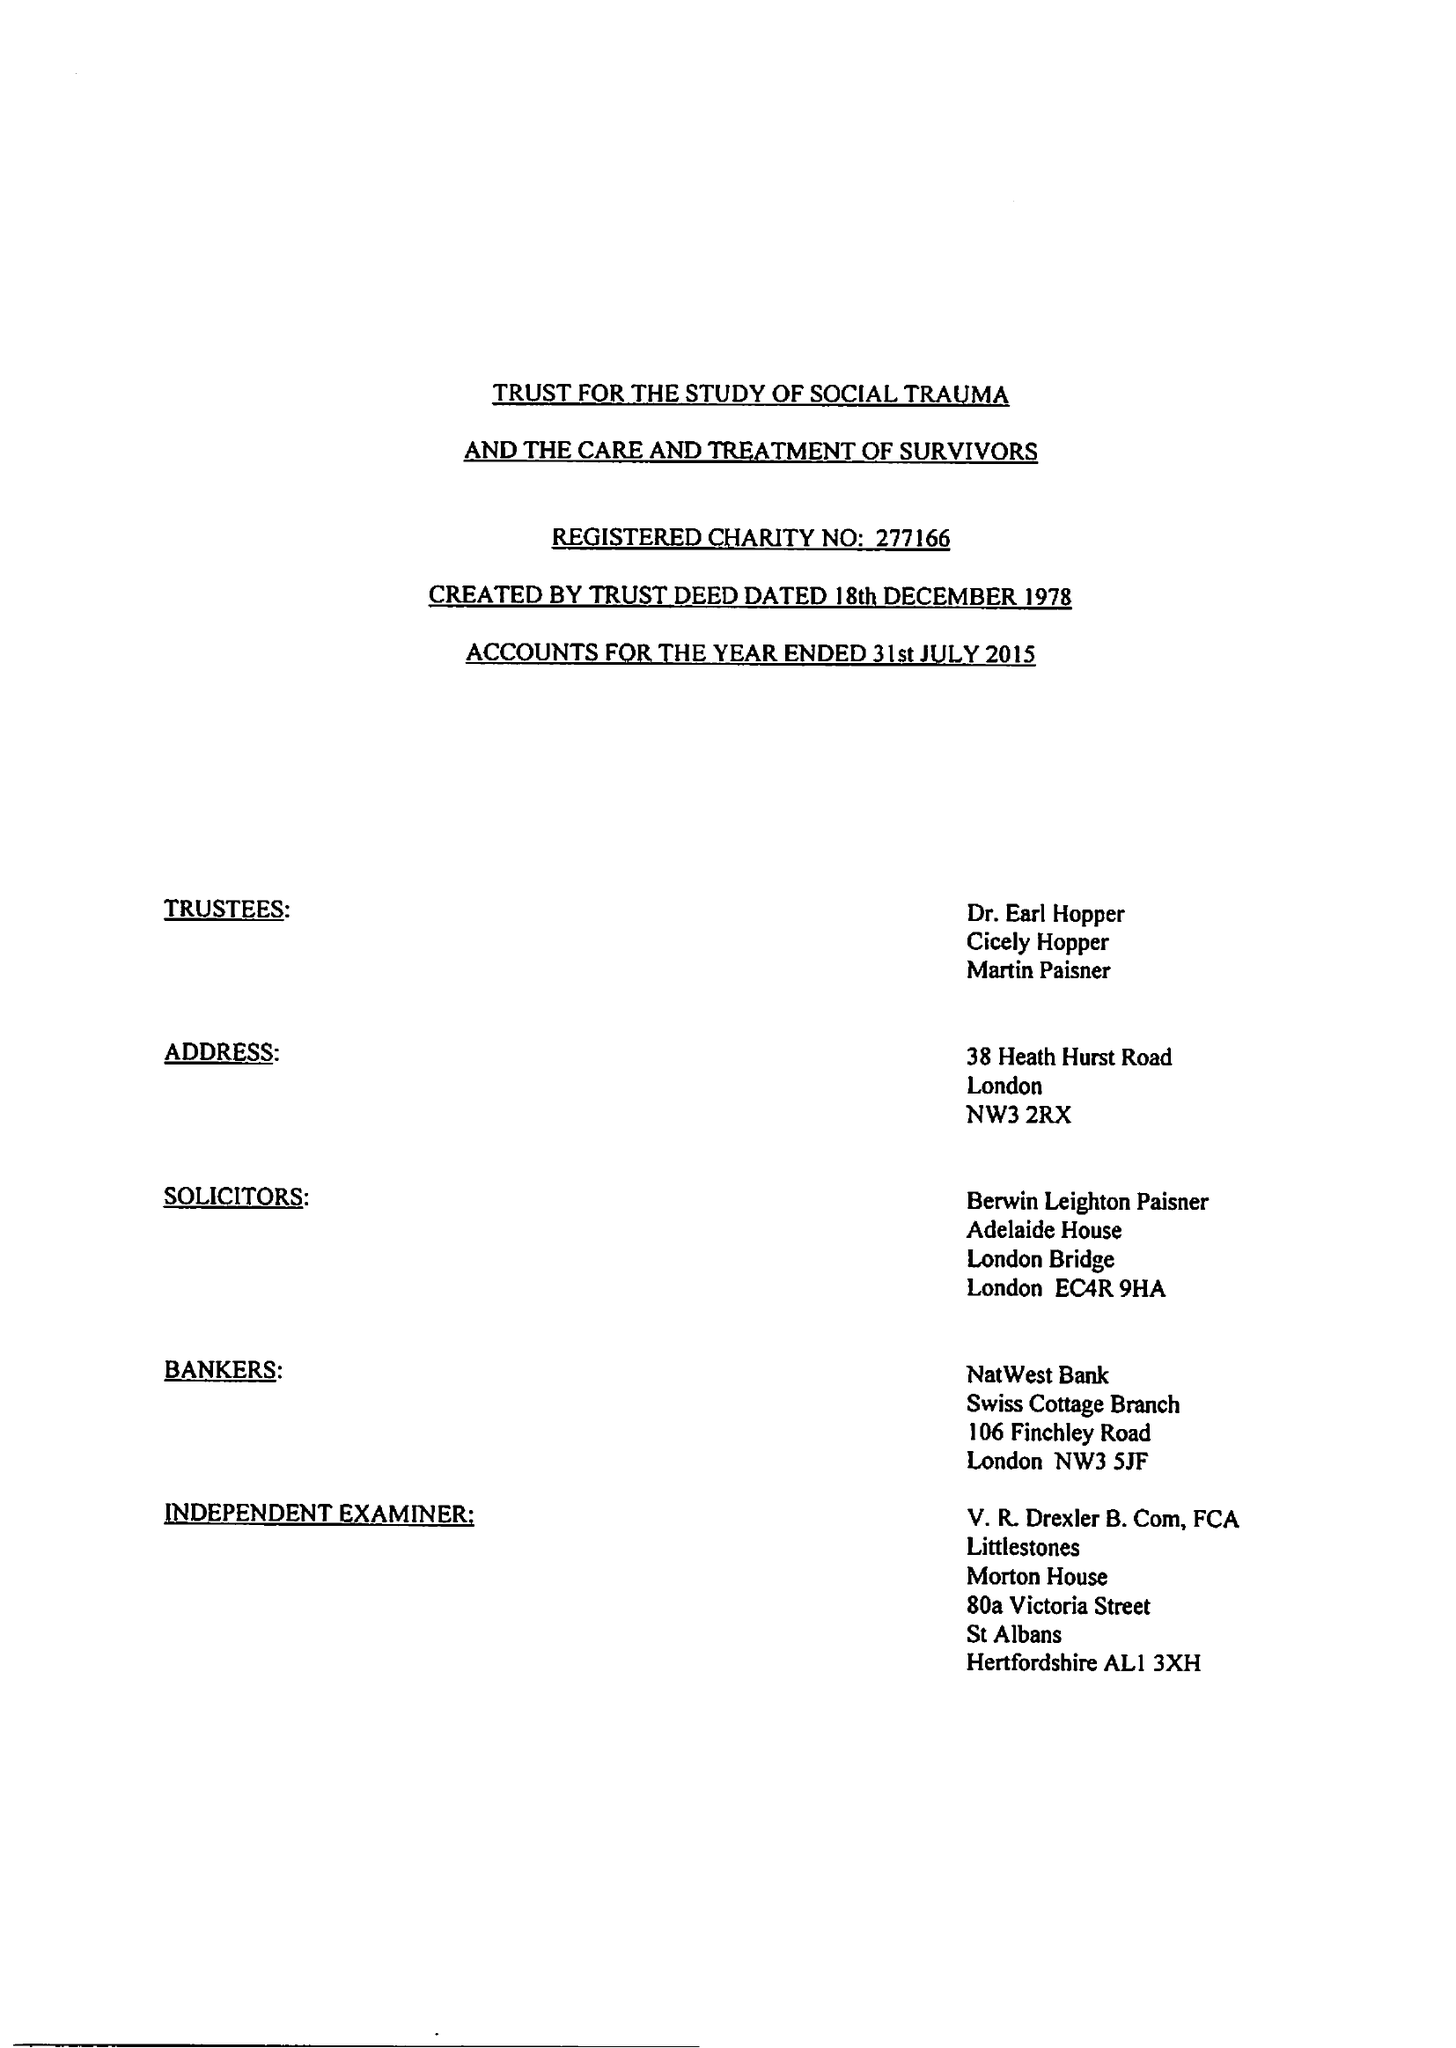What is the value for the charity_name?
Answer the question using a single word or phrase. The Trust For The Study Of Social Trauma and The Care and Treatment Of Survivors 